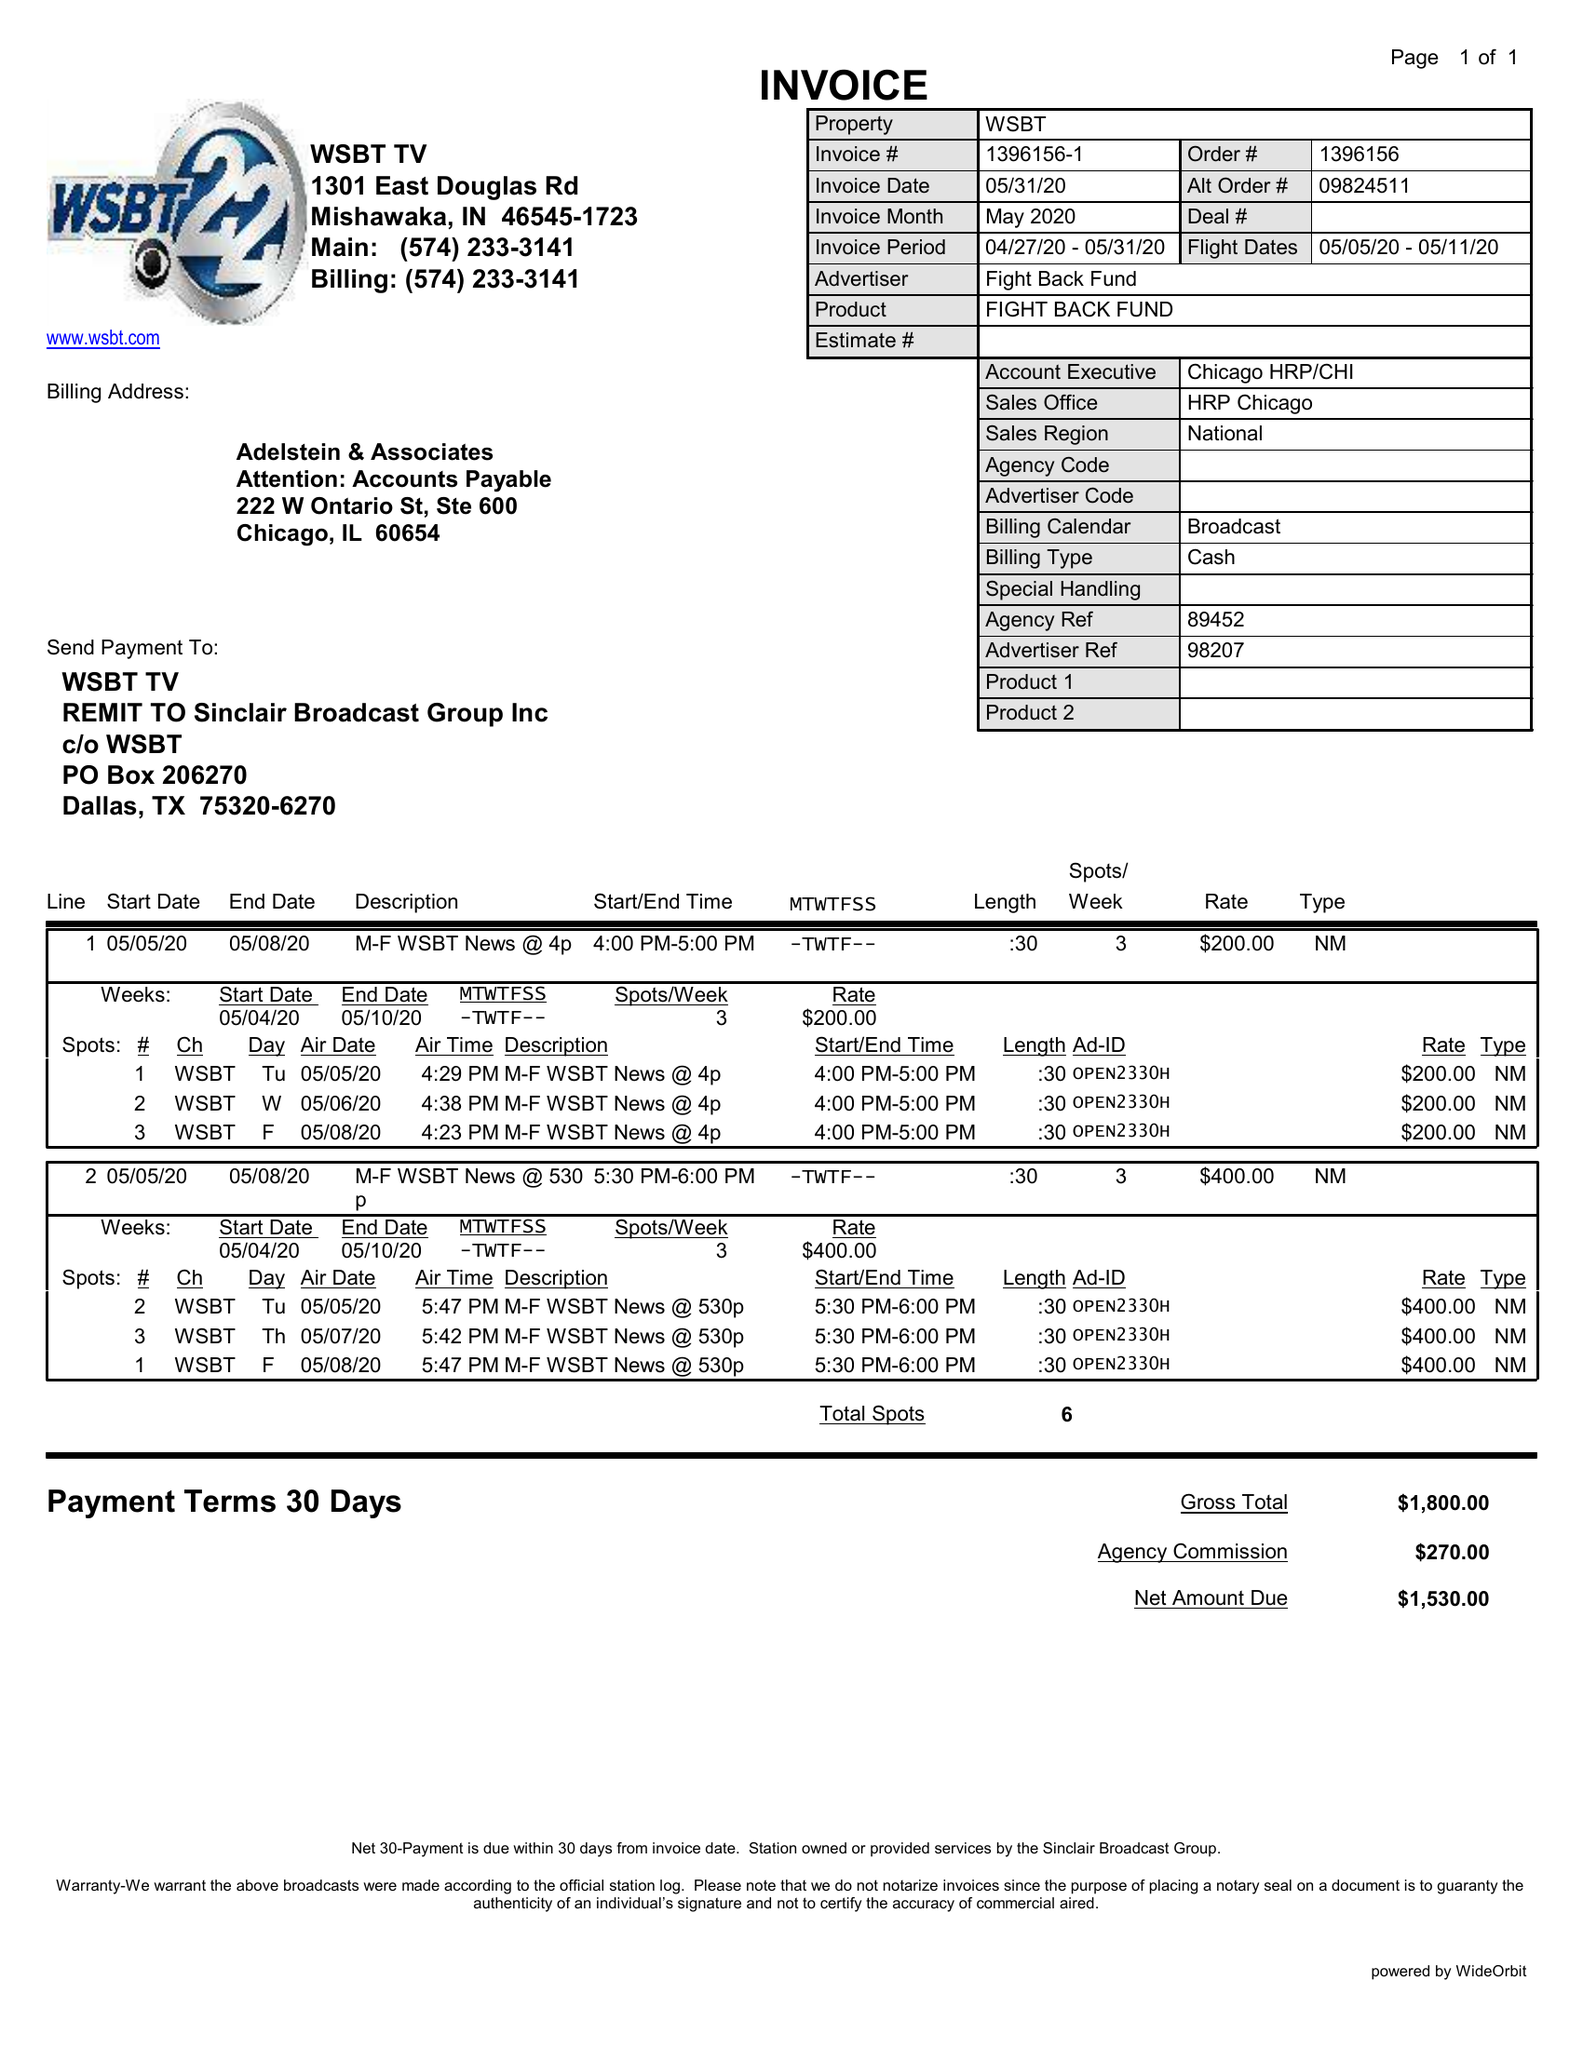What is the value for the flight_to?
Answer the question using a single word or phrase. 05/11/20 